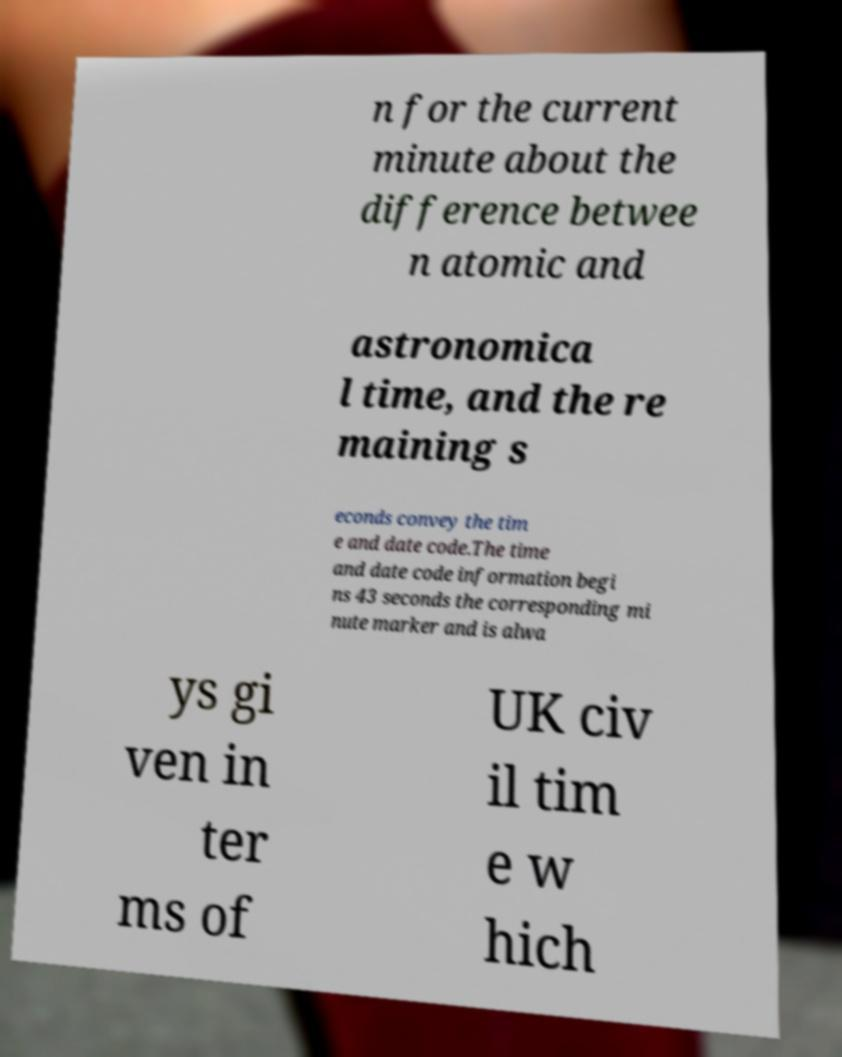I need the written content from this picture converted into text. Can you do that? n for the current minute about the difference betwee n atomic and astronomica l time, and the re maining s econds convey the tim e and date code.The time and date code information begi ns 43 seconds the corresponding mi nute marker and is alwa ys gi ven in ter ms of UK civ il tim e w hich 